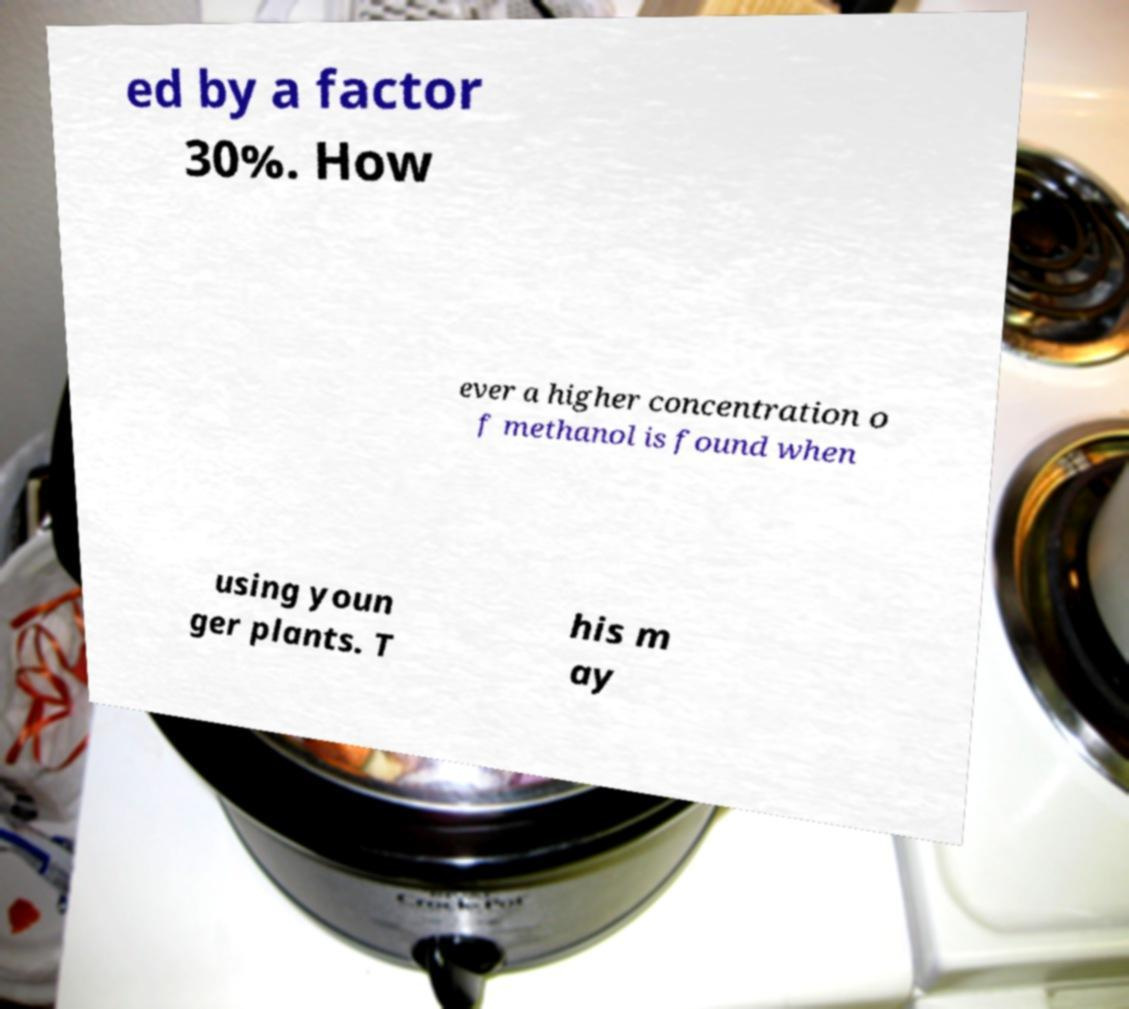There's text embedded in this image that I need extracted. Can you transcribe it verbatim? ed by a factor 30%. How ever a higher concentration o f methanol is found when using youn ger plants. T his m ay 